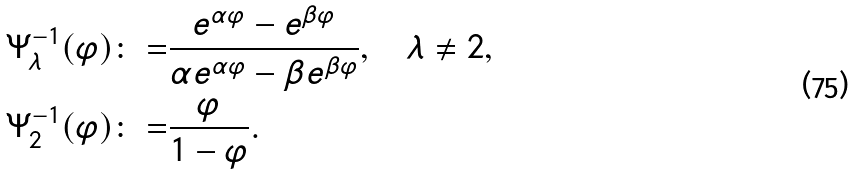<formula> <loc_0><loc_0><loc_500><loc_500>\Psi ^ { - 1 } _ { \lambda } ( \varphi ) & { \colon = } \frac { e ^ { \alpha \varphi } - e ^ { \beta \varphi } } { \alpha e ^ { \alpha \varphi } - \beta e ^ { \beta \varphi } } , \quad \lambda \ne 2 , \\ \Psi ^ { - 1 } _ { 2 } ( \varphi ) & { \colon = } \frac { \varphi } { 1 - \varphi } .</formula> 